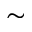Convert formula to latex. <formula><loc_0><loc_0><loc_500><loc_500>\sim</formula> 